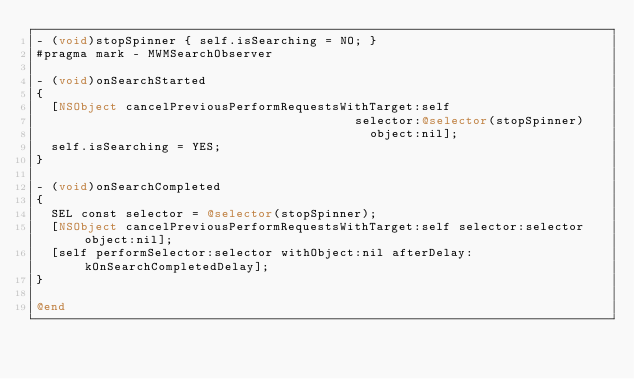Convert code to text. <code><loc_0><loc_0><loc_500><loc_500><_ObjectiveC_>- (void)stopSpinner { self.isSearching = NO; }
#pragma mark - MWMSearchObserver

- (void)onSearchStarted
{
  [NSObject cancelPreviousPerformRequestsWithTarget:self
                                           selector:@selector(stopSpinner)
                                             object:nil];
  self.isSearching = YES;
}

- (void)onSearchCompleted
{
  SEL const selector = @selector(stopSpinner);
  [NSObject cancelPreviousPerformRequestsWithTarget:self selector:selector object:nil];
  [self performSelector:selector withObject:nil afterDelay:kOnSearchCompletedDelay];
}

@end
</code> 